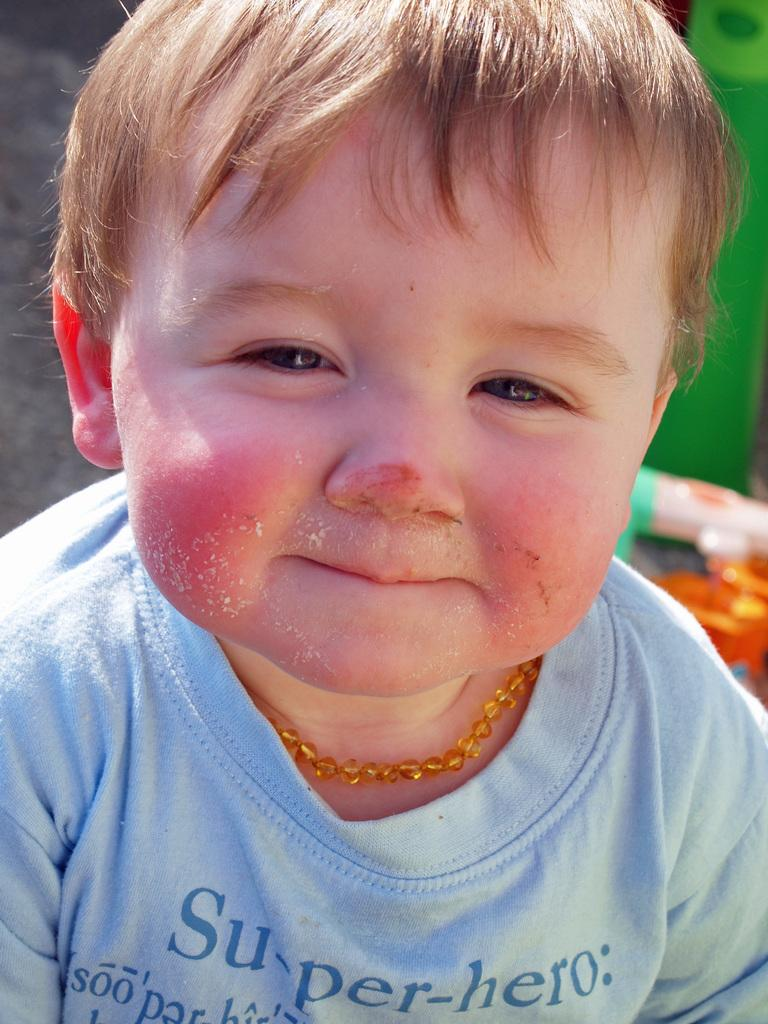What is the main subject of the image? There is a baby in the image. What is the baby wearing? The baby is wearing a blue t-shirt. Can you describe the baby's hair? The baby has gold hair. What accessory is the baby wearing around their neck? The baby is wearing a necklace around their neck. What type of stone can be seen in the image? There is no stone present in the image; it features a baby wearing a blue t-shirt, gold hair, and a necklace. 